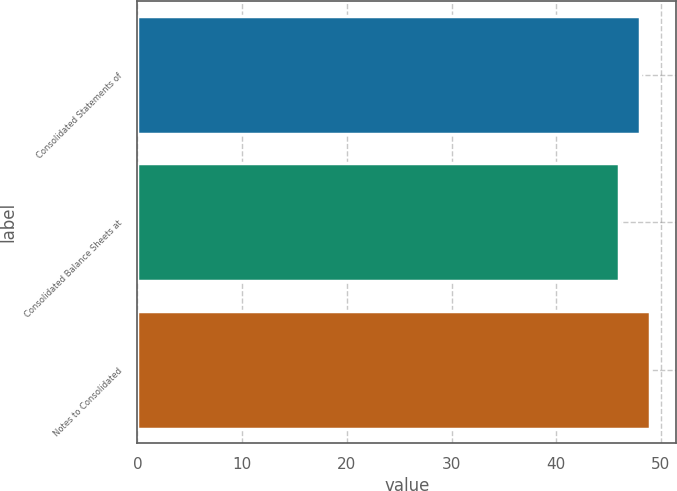Convert chart. <chart><loc_0><loc_0><loc_500><loc_500><bar_chart><fcel>Consolidated Statements of<fcel>Consolidated Balance Sheets at<fcel>Notes to Consolidated<nl><fcel>48<fcel>46<fcel>49<nl></chart> 